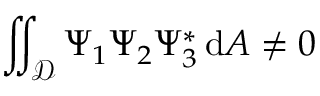<formula> <loc_0><loc_0><loc_500><loc_500>\iint _ { \mathcal { D } } \Psi _ { 1 } \Psi _ { 2 } \Psi _ { 3 } ^ { * } \, d A \neq 0</formula> 